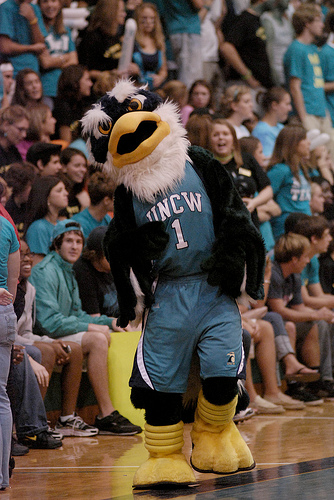<image>
Is there a mascot on the fan? No. The mascot is not positioned on the fan. They may be near each other, but the mascot is not supported by or resting on top of the fan. 